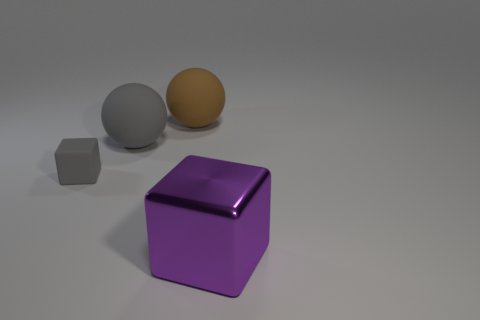Is there any other thing that is the same size as the rubber cube?
Provide a short and direct response. No. Is there a matte object that is behind the block that is on the left side of the big purple object?
Provide a succinct answer. Yes. There is a cube that is in front of the tiny gray object to the left of the big matte ball that is left of the large brown thing; how big is it?
Offer a terse response. Large. There is a cube to the right of the large sphere that is to the left of the big brown matte thing; what is its material?
Give a very brief answer. Metal. Is there a gray matte object that has the same shape as the purple object?
Give a very brief answer. Yes. What is the shape of the brown rubber object?
Keep it short and to the point. Sphere. What is the material of the gray object that is to the right of the gray rubber thing that is left of the gray object that is on the right side of the tiny gray object?
Ensure brevity in your answer.  Rubber. Is the number of brown things that are on the left side of the big shiny block greater than the number of big green rubber spheres?
Make the answer very short. Yes. There is a purple thing that is the same size as the brown rubber sphere; what is it made of?
Give a very brief answer. Metal. Is there a brown rubber ball of the same size as the gray ball?
Keep it short and to the point. Yes. 